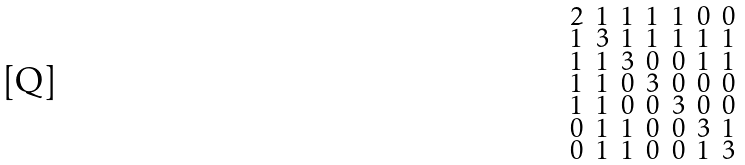<formula> <loc_0><loc_0><loc_500><loc_500>\begin{smallmatrix} 2 & 1 & 1 & 1 & 1 & 0 & 0 \\ 1 & 3 & 1 & 1 & 1 & 1 & 1 \\ 1 & 1 & 3 & 0 & 0 & 1 & 1 \\ 1 & 1 & 0 & 3 & 0 & 0 & 0 \\ 1 & 1 & 0 & 0 & 3 & 0 & 0 \\ 0 & 1 & 1 & 0 & 0 & 3 & 1 \\ 0 & 1 & 1 & 0 & 0 & 1 & 3 \end{smallmatrix}</formula> 